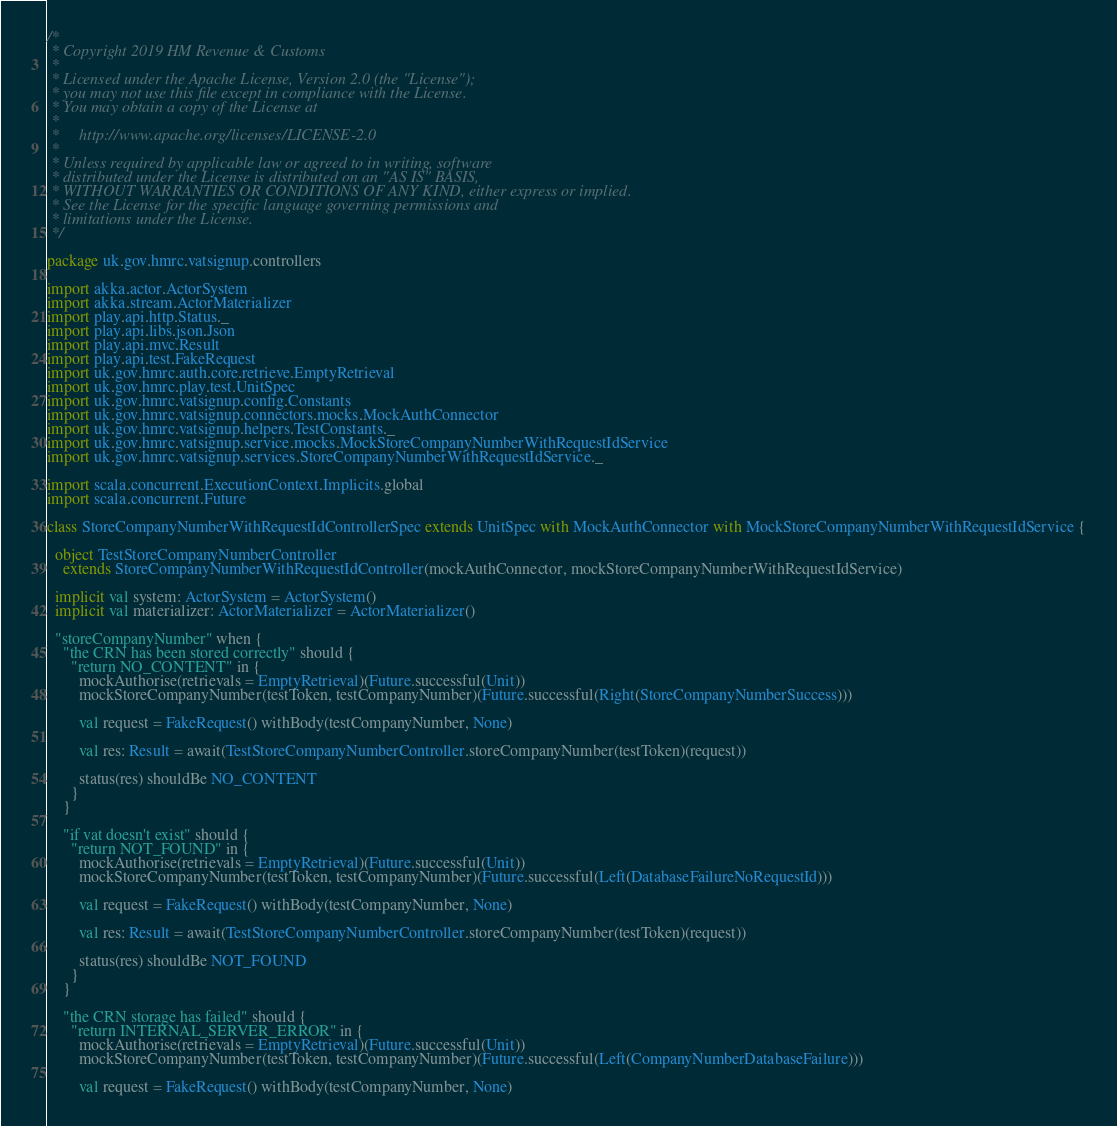<code> <loc_0><loc_0><loc_500><loc_500><_Scala_>/*
 * Copyright 2019 HM Revenue & Customs
 *
 * Licensed under the Apache License, Version 2.0 (the "License");
 * you may not use this file except in compliance with the License.
 * You may obtain a copy of the License at
 *
 *     http://www.apache.org/licenses/LICENSE-2.0
 *
 * Unless required by applicable law or agreed to in writing, software
 * distributed under the License is distributed on an "AS IS" BASIS,
 * WITHOUT WARRANTIES OR CONDITIONS OF ANY KIND, either express or implied.
 * See the License for the specific language governing permissions and
 * limitations under the License.
 */

package uk.gov.hmrc.vatsignup.controllers

import akka.actor.ActorSystem
import akka.stream.ActorMaterializer
import play.api.http.Status._
import play.api.libs.json.Json
import play.api.mvc.Result
import play.api.test.FakeRequest
import uk.gov.hmrc.auth.core.retrieve.EmptyRetrieval
import uk.gov.hmrc.play.test.UnitSpec
import uk.gov.hmrc.vatsignup.config.Constants
import uk.gov.hmrc.vatsignup.connectors.mocks.MockAuthConnector
import uk.gov.hmrc.vatsignup.helpers.TestConstants._
import uk.gov.hmrc.vatsignup.service.mocks.MockStoreCompanyNumberWithRequestIdService
import uk.gov.hmrc.vatsignup.services.StoreCompanyNumberWithRequestIdService._

import scala.concurrent.ExecutionContext.Implicits.global
import scala.concurrent.Future

class StoreCompanyNumberWithRequestIdControllerSpec extends UnitSpec with MockAuthConnector with MockStoreCompanyNumberWithRequestIdService {

  object TestStoreCompanyNumberController
    extends StoreCompanyNumberWithRequestIdController(mockAuthConnector, mockStoreCompanyNumberWithRequestIdService)

  implicit val system: ActorSystem = ActorSystem()
  implicit val materializer: ActorMaterializer = ActorMaterializer()

  "storeCompanyNumber" when {
    "the CRN has been stored correctly" should {
      "return NO_CONTENT" in {
        mockAuthorise(retrievals = EmptyRetrieval)(Future.successful(Unit))
        mockStoreCompanyNumber(testToken, testCompanyNumber)(Future.successful(Right(StoreCompanyNumberSuccess)))

        val request = FakeRequest() withBody(testCompanyNumber, None)

        val res: Result = await(TestStoreCompanyNumberController.storeCompanyNumber(testToken)(request))

        status(res) shouldBe NO_CONTENT
      }
    }

    "if vat doesn't exist" should {
      "return NOT_FOUND" in {
        mockAuthorise(retrievals = EmptyRetrieval)(Future.successful(Unit))
        mockStoreCompanyNumber(testToken, testCompanyNumber)(Future.successful(Left(DatabaseFailureNoRequestId)))

        val request = FakeRequest() withBody(testCompanyNumber, None)

        val res: Result = await(TestStoreCompanyNumberController.storeCompanyNumber(testToken)(request))

        status(res) shouldBe NOT_FOUND
      }
    }

    "the CRN storage has failed" should {
      "return INTERNAL_SERVER_ERROR" in {
        mockAuthorise(retrievals = EmptyRetrieval)(Future.successful(Unit))
        mockStoreCompanyNumber(testToken, testCompanyNumber)(Future.successful(Left(CompanyNumberDatabaseFailure)))

        val request = FakeRequest() withBody(testCompanyNumber, None)
</code> 